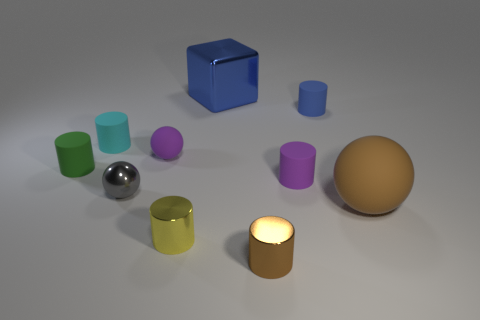What is the size of the ball that is to the right of the metal thing that is behind the green rubber object?
Offer a very short reply. Large. There is a metal object that is behind the blue rubber object; is its size the same as the tiny blue rubber cylinder?
Your answer should be compact. No. Is the number of tiny blue rubber cylinders that are on the left side of the tiny yellow cylinder greater than the number of small cyan things that are in front of the tiny cyan object?
Your answer should be compact. No. There is a object that is both right of the purple matte cylinder and behind the gray object; what is its shape?
Give a very brief answer. Cylinder. There is a object that is in front of the yellow metal thing; what shape is it?
Your answer should be very brief. Cylinder. There is a brown object that is in front of the ball that is right of the tiny sphere that is behind the small gray shiny thing; how big is it?
Ensure brevity in your answer.  Small. Is the shape of the small yellow metal object the same as the small blue object?
Provide a succinct answer. Yes. How big is the matte thing that is both right of the big metallic thing and on the left side of the blue rubber object?
Offer a terse response. Small. What is the material of the small green thing that is the same shape as the blue matte object?
Provide a short and direct response. Rubber. What is the large object that is in front of the matte sphere that is on the left side of the small blue rubber cylinder made of?
Keep it short and to the point. Rubber. 